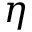Convert formula to latex. <formula><loc_0><loc_0><loc_500><loc_500>\eta</formula> 